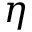Convert formula to latex. <formula><loc_0><loc_0><loc_500><loc_500>\eta</formula> 